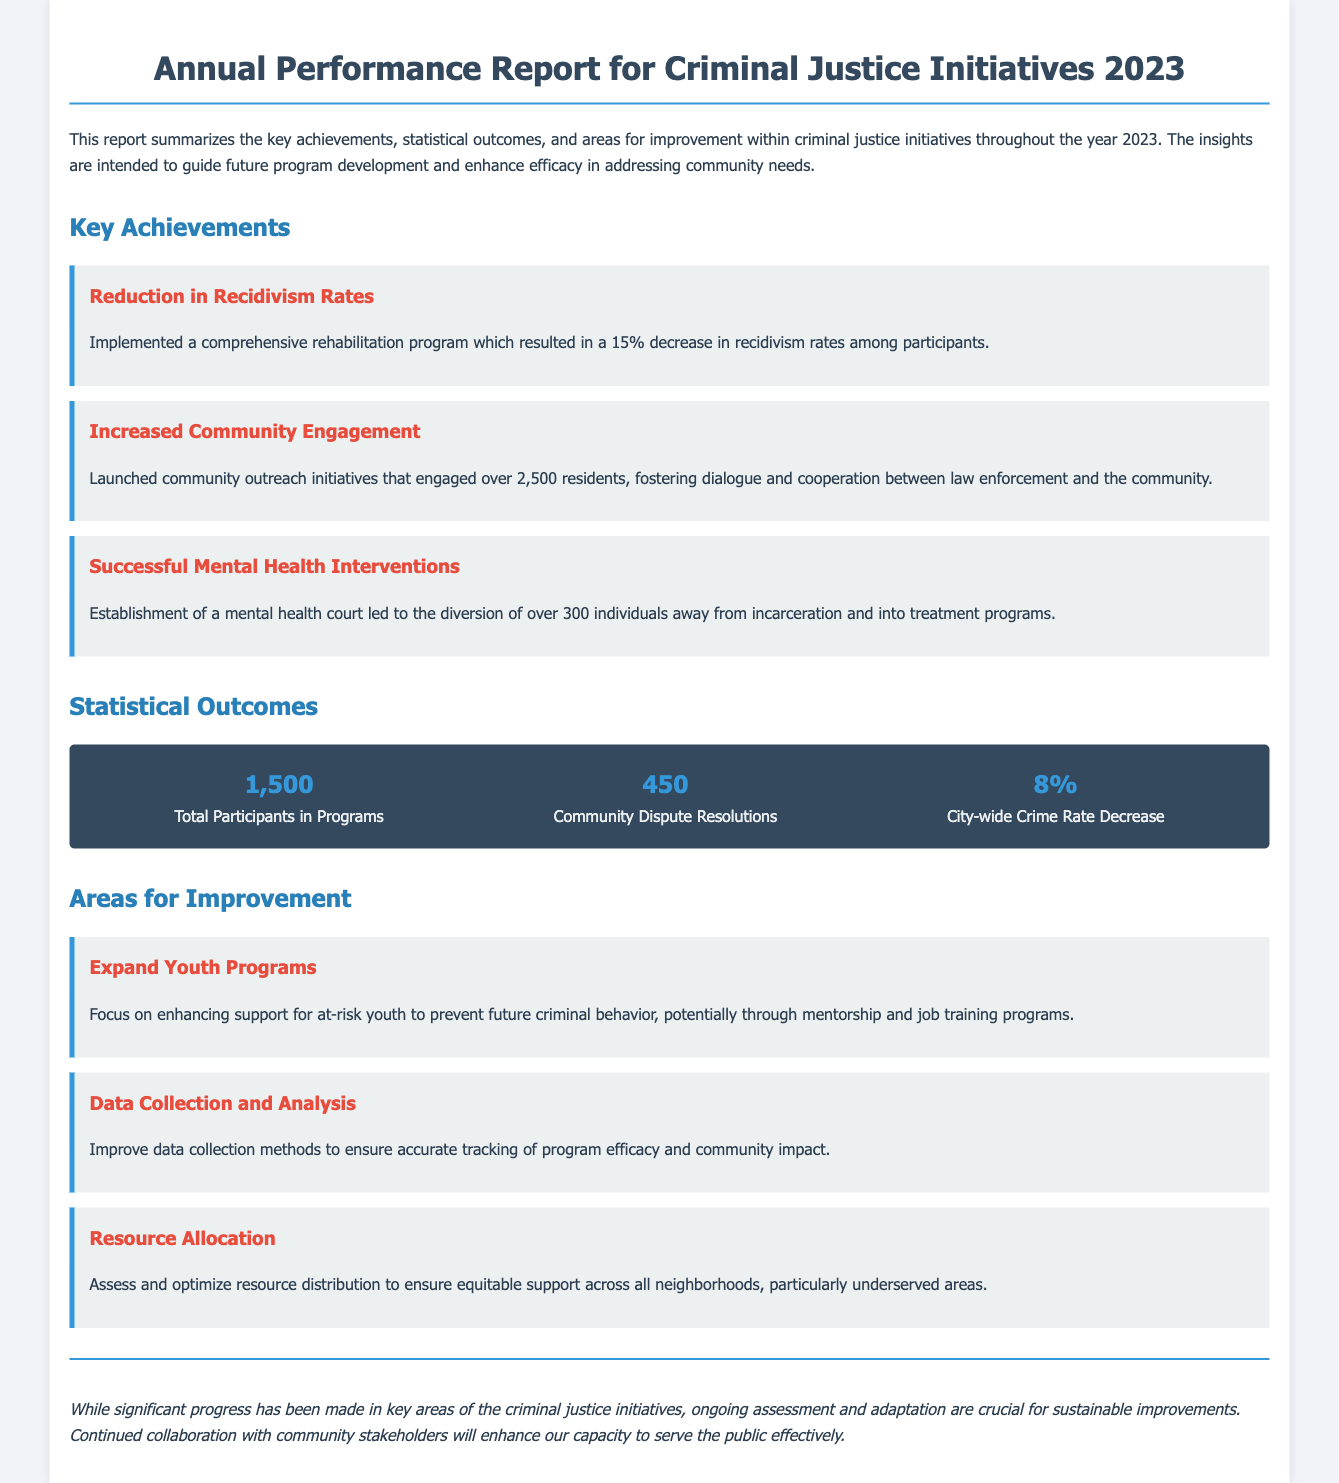What was the percentage decrease in recidivism rates? The report states a 15% decrease in recidivism rates among participants due to a comprehensive rehabilitation program.
Answer: 15% How many residents were engaged through community outreach initiatives? The document mentions that over 2,500 residents were engaged in the community outreach initiatives.
Answer: 2,500 How many total participants were there in the programs? The statistical outcomes section lists a total of 1,500 participants in programs throughout the year.
Answer: 1,500 What was the percent decrease in the city-wide crime rate? The report indicates an 8% decrease in the city-wide crime rate.
Answer: 8% What area needs improvement regarding data? The document highlights the need to improve data collection methods for better tracking of program efficacy and community impact.
Answer: Data Collection and Analysis What specific type of court was established for mental health interventions? The report refers to the establishment of a mental health court aimed at diverting individuals from incarceration.
Answer: Mental Health Court How many community dispute resolutions were recorded? According to the statistical outcomes, there were 450 community dispute resolutions recorded.
Answer: 450 What is a suggested focus to prevent future criminal behavior? The document suggests focusing on enhancing support for at-risk youth through mentorship and job training programs.
Answer: Expand Youth Programs What is the conclusion of the report? The report concludes that ongoing assessment and adaptation are crucial for sustainable improvements in criminal justice initiatives.
Answer: Ongoing assessment and adaptation are crucial 